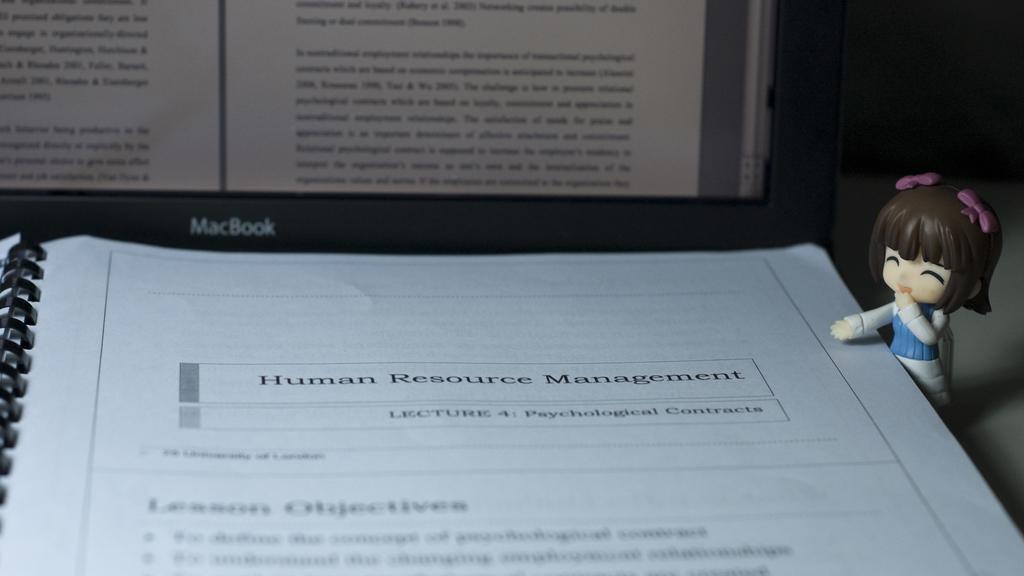How would you summarize this image in a sentence or two? In this image there is a book. There is text on the book. To the left there is a spiral binding to the book. To the right there is a small doll beside the book. In the background there is a laptop. There is text on the laptop. 